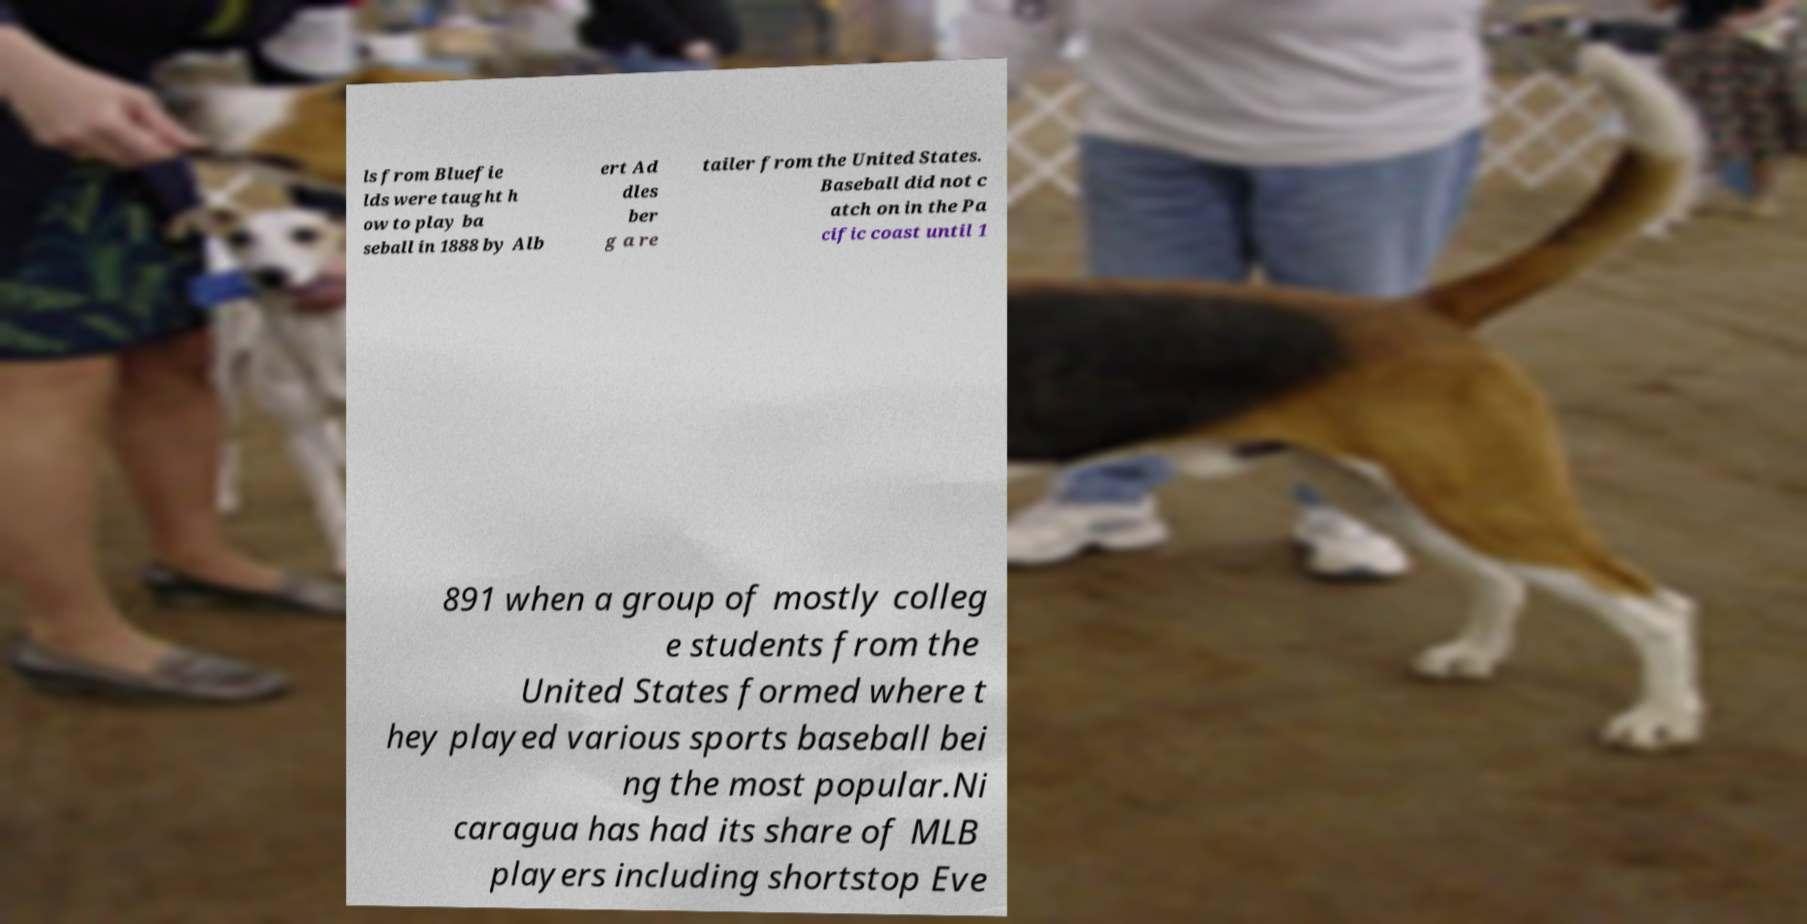Can you read and provide the text displayed in the image?This photo seems to have some interesting text. Can you extract and type it out for me? ls from Bluefie lds were taught h ow to play ba seball in 1888 by Alb ert Ad dles ber g a re tailer from the United States. Baseball did not c atch on in the Pa cific coast until 1 891 when a group of mostly colleg e students from the United States formed where t hey played various sports baseball bei ng the most popular.Ni caragua has had its share of MLB players including shortstop Eve 